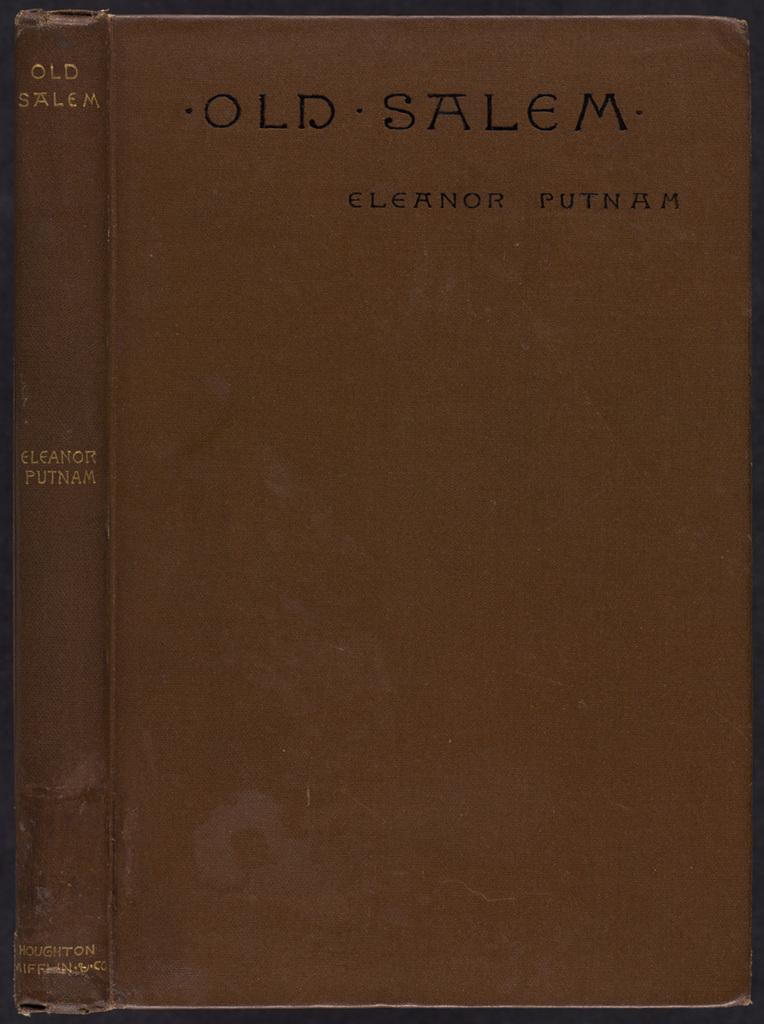<image>
Give a short and clear explanation of the subsequent image. An old brown book is shown titled, "Old Salem" by Eleanor Putnam. 